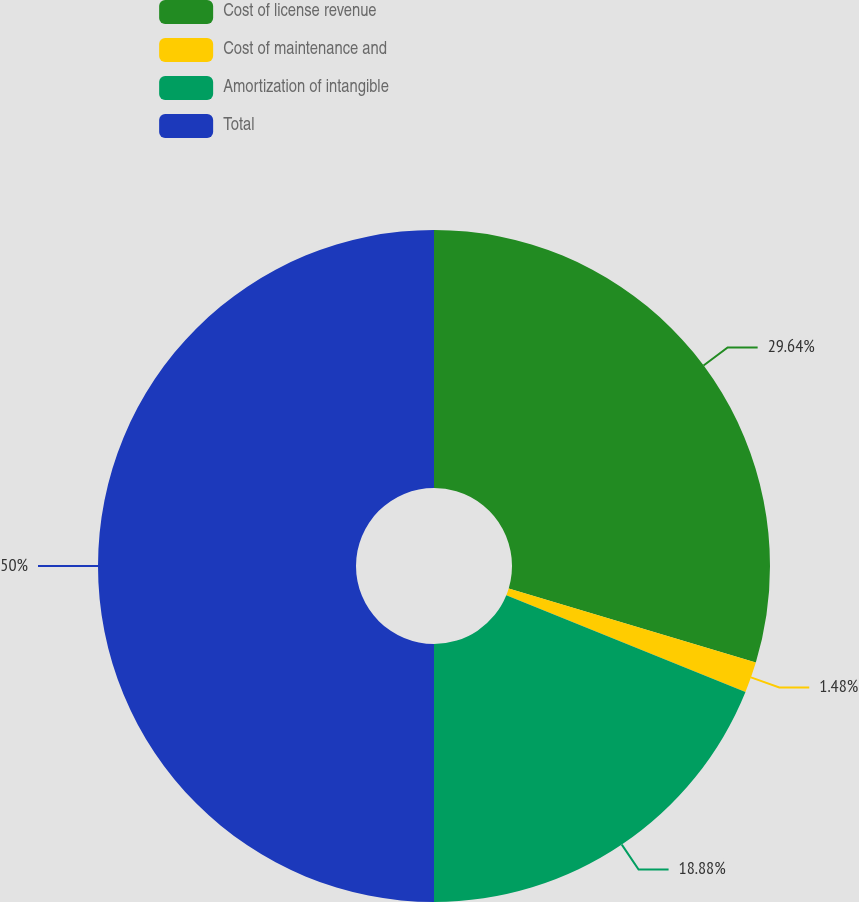Convert chart. <chart><loc_0><loc_0><loc_500><loc_500><pie_chart><fcel>Cost of license revenue<fcel>Cost of maintenance and<fcel>Amortization of intangible<fcel>Total<nl><fcel>29.64%<fcel>1.48%<fcel>18.88%<fcel>50.0%<nl></chart> 